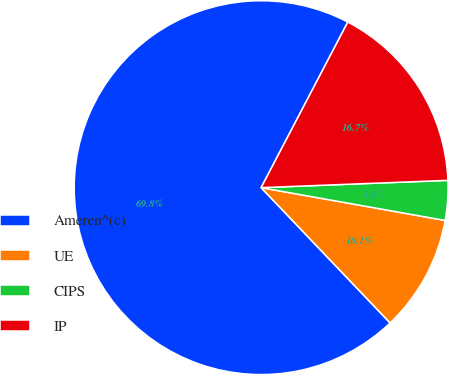Convert chart. <chart><loc_0><loc_0><loc_500><loc_500><pie_chart><fcel>Ameren^(c)<fcel>UE<fcel>CIPS<fcel>IP<nl><fcel>69.79%<fcel>10.07%<fcel>3.43%<fcel>16.7%<nl></chart> 